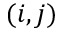Convert formula to latex. <formula><loc_0><loc_0><loc_500><loc_500>( i , j )</formula> 